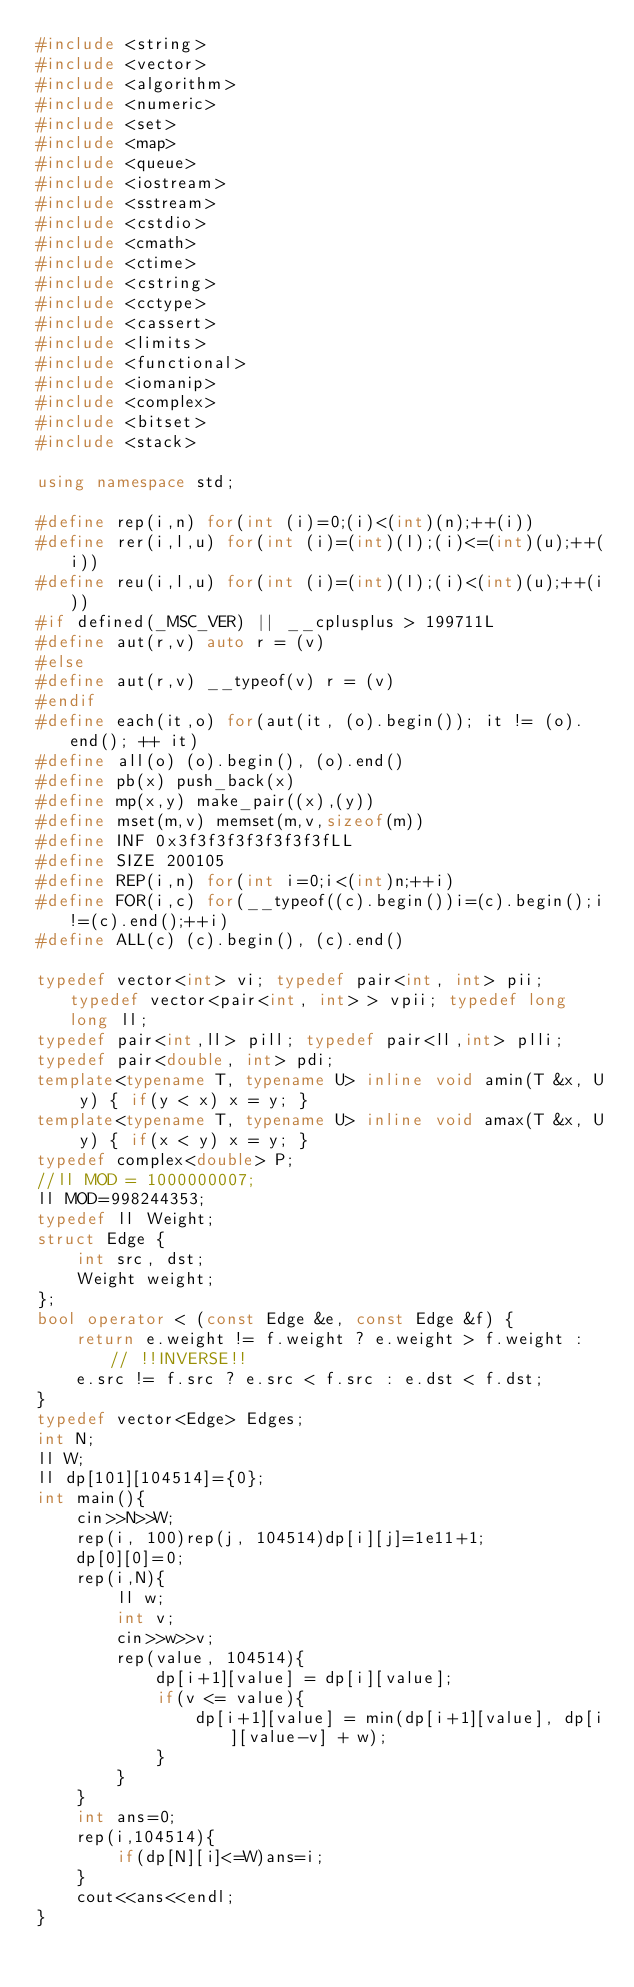Convert code to text. <code><loc_0><loc_0><loc_500><loc_500><_C++_>#include <string>
#include <vector>
#include <algorithm>
#include <numeric>
#include <set>
#include <map>
#include <queue>
#include <iostream>
#include <sstream>
#include <cstdio>
#include <cmath>
#include <ctime>
#include <cstring>
#include <cctype>
#include <cassert>
#include <limits>
#include <functional>
#include <iomanip>
#include <complex>
#include <bitset>
#include <stack>
 
using namespace std;
 
#define rep(i,n) for(int (i)=0;(i)<(int)(n);++(i))
#define rer(i,l,u) for(int (i)=(int)(l);(i)<=(int)(u);++(i))
#define reu(i,l,u) for(int (i)=(int)(l);(i)<(int)(u);++(i))
#if defined(_MSC_VER) || __cplusplus > 199711L
#define aut(r,v) auto r = (v)
#else
#define aut(r,v) __typeof(v) r = (v)
#endif
#define each(it,o) for(aut(it, (o).begin()); it != (o).end(); ++ it)
#define all(o) (o).begin(), (o).end()
#define pb(x) push_back(x)
#define mp(x,y) make_pair((x),(y))
#define mset(m,v) memset(m,v,sizeof(m))
#define INF 0x3f3f3f3f3f3f3f3fLL
#define SIZE 200105
#define REP(i,n) for(int i=0;i<(int)n;++i)
#define FOR(i,c) for(__typeof((c).begin())i=(c).begin();i!=(c).end();++i)
#define ALL(c) (c).begin(), (c).end()
 
typedef vector<int> vi; typedef pair<int, int> pii; typedef vector<pair<int, int> > vpii; typedef long long ll;
typedef pair<int,ll> pill; typedef pair<ll,int> plli; 
typedef pair<double, int> pdi;
template<typename T, typename U> inline void amin(T &x, U y) { if(y < x) x = y; }
template<typename T, typename U> inline void amax(T &x, U y) { if(x < y) x = y; }
typedef complex<double> P;
//ll MOD = 1000000007;
ll MOD=998244353;
typedef ll Weight;
struct Edge {
	int src, dst;
	Weight weight;
};
bool operator < (const Edge &e, const Edge &f) {
	return e.weight != f.weight ? e.weight > f.weight : // !!INVERSE!!
	e.src != f.src ? e.src < f.src : e.dst < f.dst;
}
typedef vector<Edge> Edges;
int N;
ll W;
ll dp[101][104514]={0};
int main(){
	cin>>N>>W;
	rep(i, 100)rep(j, 104514)dp[i][j]=1e11+1;
	dp[0][0]=0;
	rep(i,N){
		ll w;
		int v;
		cin>>w>>v;
		rep(value, 104514){
			dp[i+1][value] = dp[i][value];
			if(v <= value){
				dp[i+1][value] = min(dp[i+1][value], dp[i][value-v] + w);
			}
		}
	}
	int ans=0;
	rep(i,104514){
		if(dp[N][i]<=W)ans=i;
	}
	cout<<ans<<endl;
}</code> 